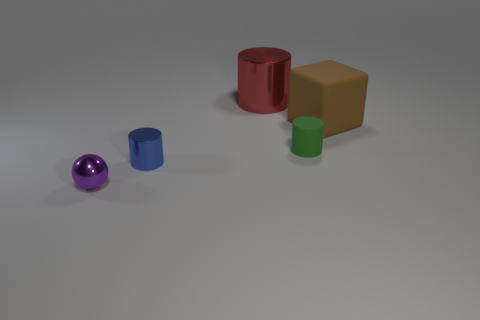Is the shape of the big brown matte object the same as the blue metallic thing?
Provide a short and direct response. No. What number of objects are right of the small metallic cylinder and to the left of the large brown object?
Your answer should be compact. 2. What number of shiny objects are either gray cylinders or tiny objects?
Provide a short and direct response. 2. How big is the cylinder that is to the right of the metal cylinder that is behind the big brown object?
Provide a short and direct response. Small. Is there a large red shiny thing that is in front of the large thing on the right side of the matte thing that is left of the large brown rubber object?
Keep it short and to the point. No. Is the material of the tiny object that is right of the big metallic object the same as the small cylinder that is in front of the small rubber thing?
Offer a very short reply. No. How many objects are small spheres or shiny objects on the right side of the small ball?
Your answer should be compact. 3. How many large red metal things are the same shape as the purple metal thing?
Offer a very short reply. 0. What is the material of the green thing that is the same size as the purple ball?
Your answer should be compact. Rubber. What size is the metallic cylinder in front of the thing behind the large object that is in front of the big red metal cylinder?
Give a very brief answer. Small. 